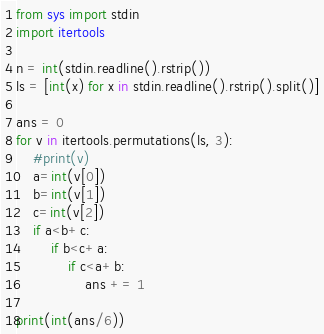Convert code to text. <code><loc_0><loc_0><loc_500><loc_500><_Python_>
from sys import stdin
import itertools

n = int(stdin.readline().rstrip())
ls = [int(x) for x in stdin.readline().rstrip().split()]

ans = 0
for v in itertools.permutations(ls, 3):
    #print(v)
    a=int(v[0])
    b=int(v[1])
    c=int(v[2])
    if a<b+c:
        if b<c+a:
            if c<a+b:
                ans += 1

print(int(ans/6))
</code> 